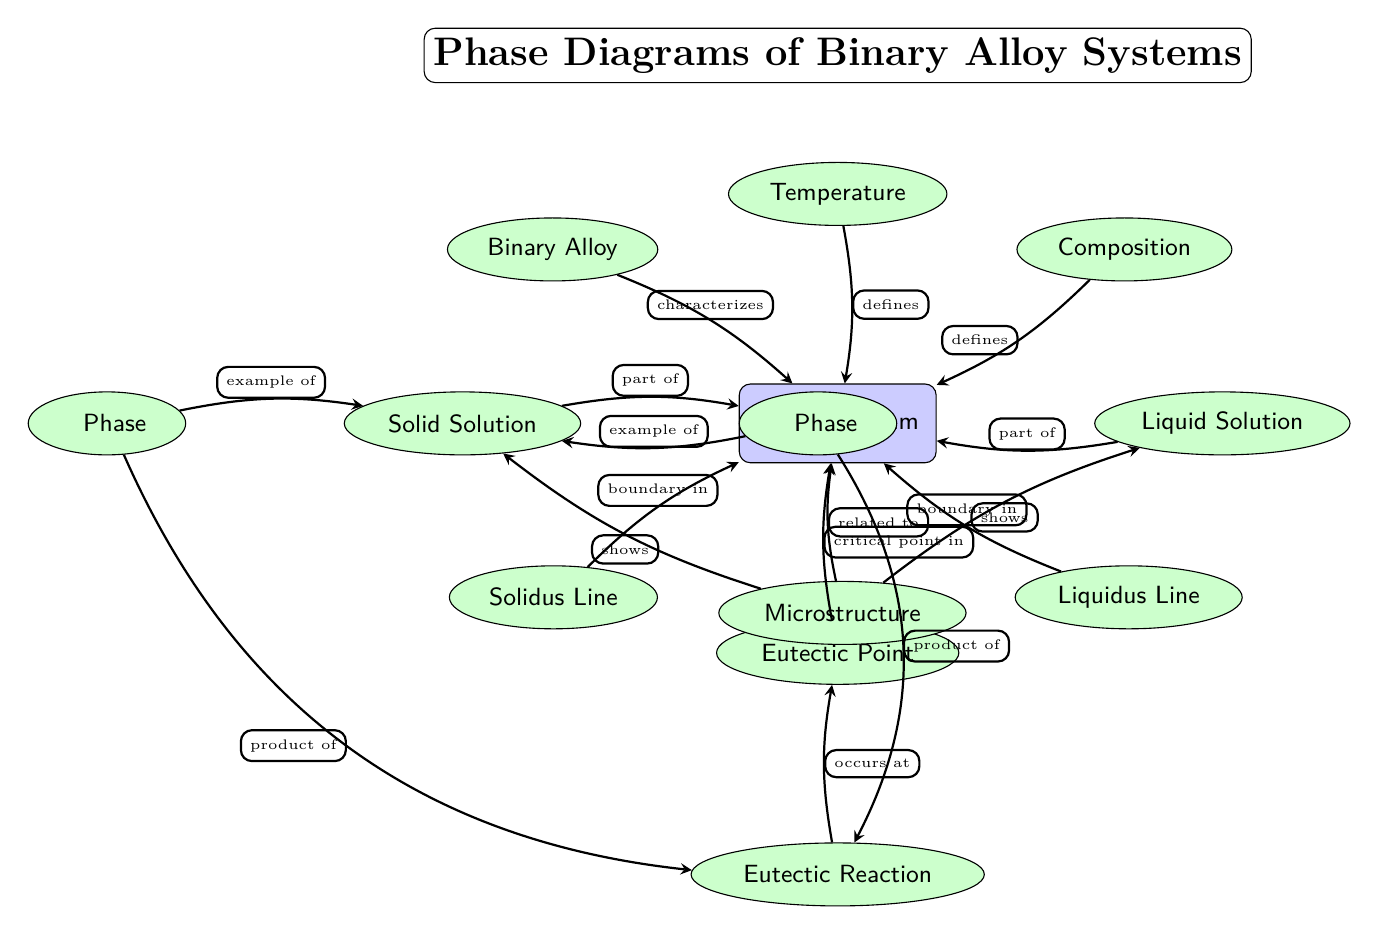What is the critical point labeled in the diagram? The diagram places "Eutectic Point" directly below the main "Phase Diagram" node, indicating that this is the critical point being referred to.
Answer: Eutectic Point What are the two phases represented in the diagram? The diagram includes two nodes titled "Solid Solution" and "Liquid Solution," which are the two phases of the binary alloy system described.
Answer: Solid Solution, Liquid Solution How many boundary lines are depicted in the diagram? The diagram features two boundary lines labeled "Solidus Line" and "Liquidus Line," showing the boundaries between phases in this system.
Answer: 2 What does the 'Eutectic Reaction' occur at? The 'Eutectic Reaction' node is positioned directly below the 'Eutectic Point' node, indicating that the reaction occurs at this critical point.
Answer: Eutectic Point Which phase is an example of the α Phase? The diagram indicates that to the left of the "Solid Solution" phase node, there is the "α Phase," making it clear that this phase is an example associated with solid solutions.
Answer: α Phase What type of structure is shown related to the "Phase Diagram"? The node "Microstructure" is connected to the "Phase Diagram," illustrating that microstructure is a concept that is directly related to the phase diagram.
Answer: Microstructure What relationships are indicated between the phases and the eutectic reaction? The diagram indicates that both the "α Phase" and "β Phase" are connected to the "Eutectic Reaction," showcasing that they are products of this reaction.
Answer: Product of Eutectic Reaction What defines the axis on the left side of the diagram? The left axis of the diagram is labeled "Composition," which describes the varying proportions of the alloying elements as part of the phase diagram.
Answer: Composition Which phases are shown as parts of the overall Phase Diagram? The "Solid Solution" and "Liquid Solution" are indicated as part of the "Phase Diagram," as stated by the edges connecting them.
Answer: Solid Solution, Liquid Solution 